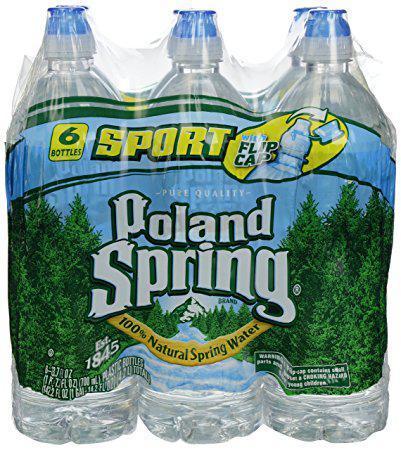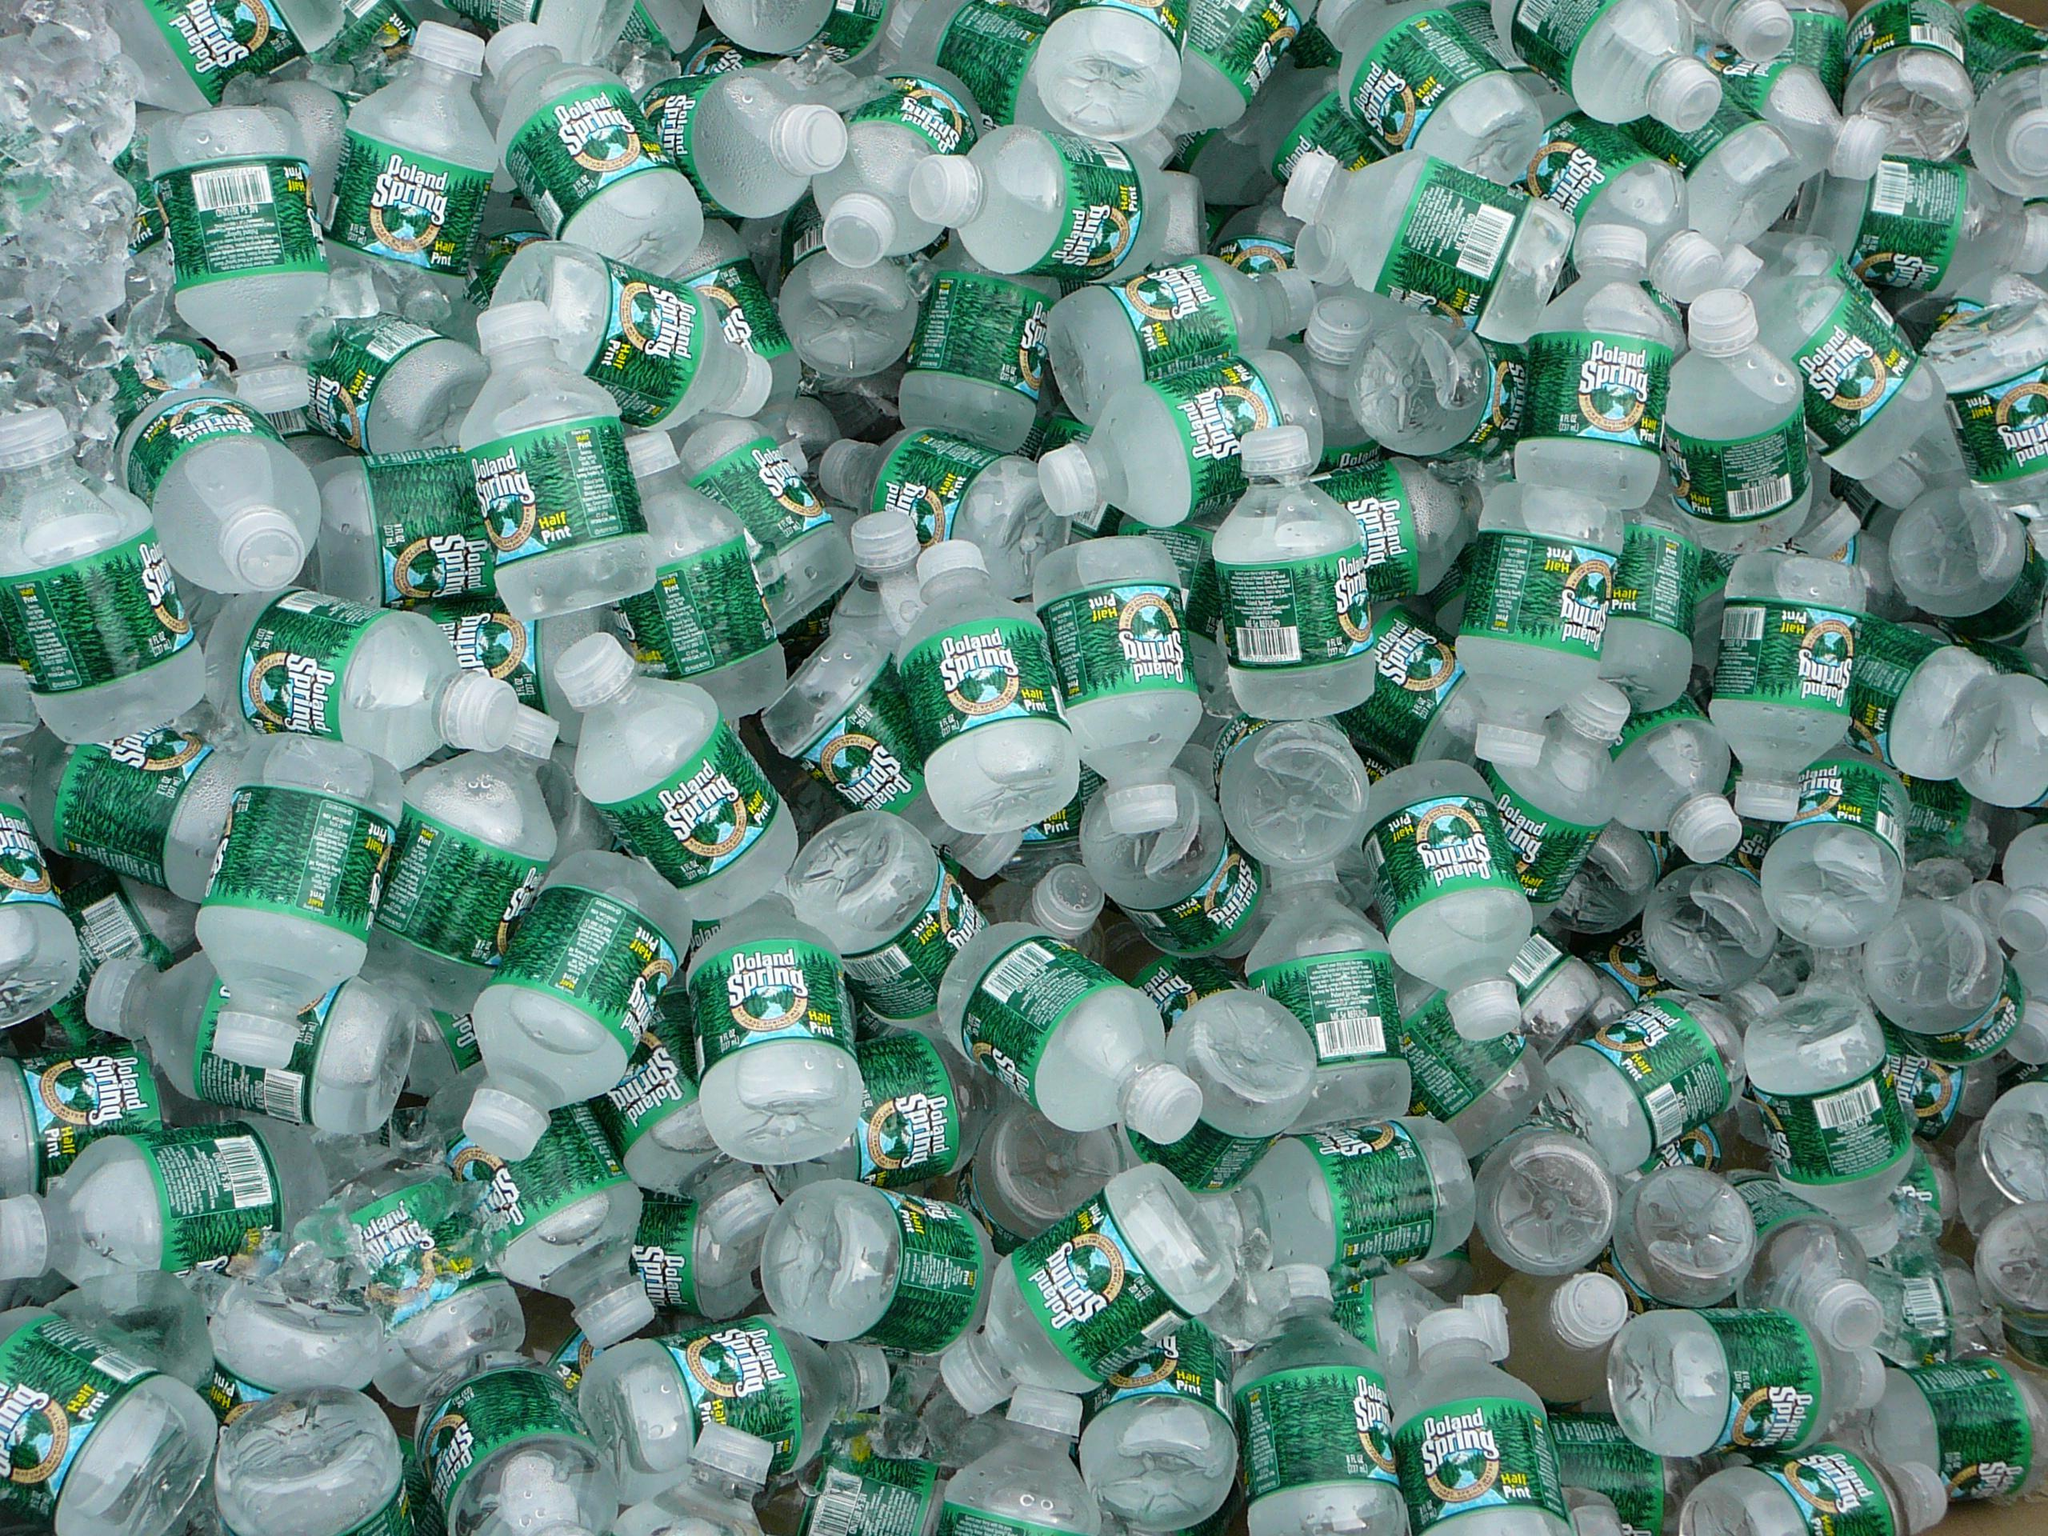The first image is the image on the left, the second image is the image on the right. Examine the images to the left and right. Is the description "At least one image shows a large mass of water bottles." accurate? Answer yes or no. Yes. 